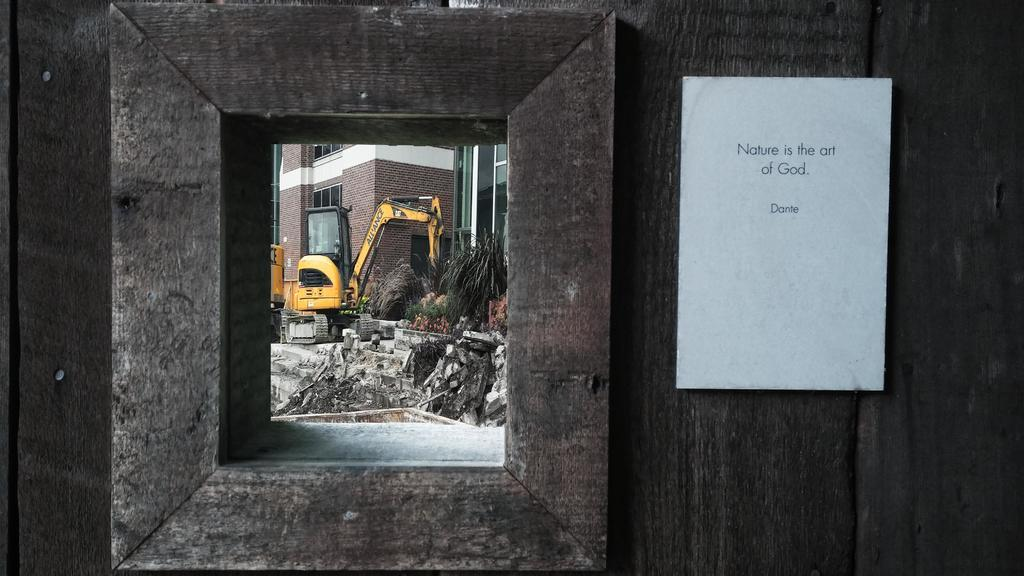What is the main object in the image? There is a whiteboard in the image. What is the background of the whiteboard made of? The whiteboard is on a wooden background. What type of construction equipment can be seen in the image? There is a crane visible in the image. What can be seen in the background of the image? Plants, bricks, and buildings are present in the background of the image. What is the purpose of the glass in the image? The purpose of the glass in the image is not specified, but it could be for drinking or holding a liquid. What type of caption is written on the whiteboard in the image? There is no caption written on the whiteboard in the image. How many chickens are visible in the image? There are no chickens present in the image. 